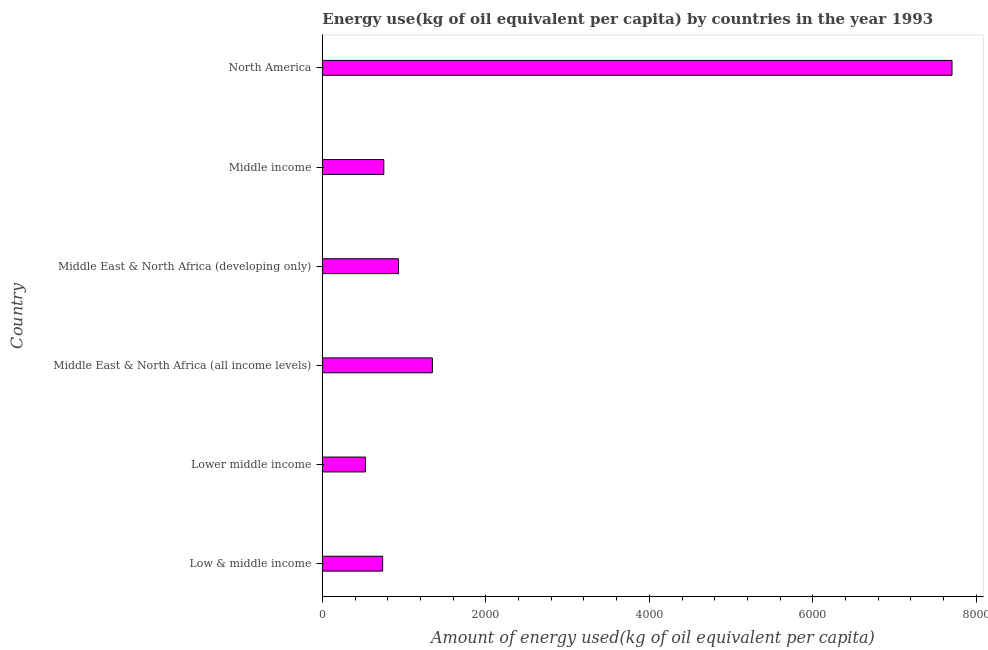Does the graph contain any zero values?
Provide a short and direct response. No. Does the graph contain grids?
Provide a succinct answer. No. What is the title of the graph?
Offer a terse response. Energy use(kg of oil equivalent per capita) by countries in the year 1993. What is the label or title of the X-axis?
Make the answer very short. Amount of energy used(kg of oil equivalent per capita). What is the amount of energy used in Lower middle income?
Keep it short and to the point. 527.1. Across all countries, what is the maximum amount of energy used?
Your answer should be compact. 7702.71. Across all countries, what is the minimum amount of energy used?
Provide a short and direct response. 527.1. In which country was the amount of energy used minimum?
Provide a succinct answer. Lower middle income. What is the sum of the amount of energy used?
Provide a short and direct response. 1.20e+04. What is the difference between the amount of energy used in Lower middle income and North America?
Your answer should be very brief. -7175.6. What is the average amount of energy used per country?
Offer a very short reply. 1999.72. What is the median amount of energy used?
Make the answer very short. 842.21. In how many countries, is the amount of energy used greater than 800 kg?
Your response must be concise. 3. What is the ratio of the amount of energy used in Middle East & North Africa (all income levels) to that in Middle income?
Offer a very short reply. 1.79. Is the difference between the amount of energy used in Middle East & North Africa (all income levels) and Middle income greater than the difference between any two countries?
Your answer should be very brief. No. What is the difference between the highest and the second highest amount of energy used?
Make the answer very short. 6356.54. Is the sum of the amount of energy used in Lower middle income and North America greater than the maximum amount of energy used across all countries?
Give a very brief answer. Yes. What is the difference between the highest and the lowest amount of energy used?
Keep it short and to the point. 7175.6. Are all the bars in the graph horizontal?
Ensure brevity in your answer.  Yes. What is the difference between two consecutive major ticks on the X-axis?
Ensure brevity in your answer.  2000. What is the Amount of energy used(kg of oil equivalent per capita) of Low & middle income?
Your answer should be very brief. 737.95. What is the Amount of energy used(kg of oil equivalent per capita) of Lower middle income?
Your response must be concise. 527.1. What is the Amount of energy used(kg of oil equivalent per capita) of Middle East & North Africa (all income levels)?
Your answer should be very brief. 1346.17. What is the Amount of energy used(kg of oil equivalent per capita) in Middle East & North Africa (developing only)?
Offer a terse response. 932.44. What is the Amount of energy used(kg of oil equivalent per capita) of Middle income?
Give a very brief answer. 751.97. What is the Amount of energy used(kg of oil equivalent per capita) of North America?
Your answer should be very brief. 7702.71. What is the difference between the Amount of energy used(kg of oil equivalent per capita) in Low & middle income and Lower middle income?
Provide a short and direct response. 210.84. What is the difference between the Amount of energy used(kg of oil equivalent per capita) in Low & middle income and Middle East & North Africa (all income levels)?
Ensure brevity in your answer.  -608.22. What is the difference between the Amount of energy used(kg of oil equivalent per capita) in Low & middle income and Middle East & North Africa (developing only)?
Make the answer very short. -194.49. What is the difference between the Amount of energy used(kg of oil equivalent per capita) in Low & middle income and Middle income?
Give a very brief answer. -14.02. What is the difference between the Amount of energy used(kg of oil equivalent per capita) in Low & middle income and North America?
Ensure brevity in your answer.  -6964.76. What is the difference between the Amount of energy used(kg of oil equivalent per capita) in Lower middle income and Middle East & North Africa (all income levels)?
Give a very brief answer. -819.07. What is the difference between the Amount of energy used(kg of oil equivalent per capita) in Lower middle income and Middle East & North Africa (developing only)?
Offer a very short reply. -405.34. What is the difference between the Amount of energy used(kg of oil equivalent per capita) in Lower middle income and Middle income?
Your response must be concise. -224.86. What is the difference between the Amount of energy used(kg of oil equivalent per capita) in Lower middle income and North America?
Give a very brief answer. -7175.6. What is the difference between the Amount of energy used(kg of oil equivalent per capita) in Middle East & North Africa (all income levels) and Middle East & North Africa (developing only)?
Ensure brevity in your answer.  413.73. What is the difference between the Amount of energy used(kg of oil equivalent per capita) in Middle East & North Africa (all income levels) and Middle income?
Your answer should be compact. 594.2. What is the difference between the Amount of energy used(kg of oil equivalent per capita) in Middle East & North Africa (all income levels) and North America?
Provide a succinct answer. -6356.54. What is the difference between the Amount of energy used(kg of oil equivalent per capita) in Middle East & North Africa (developing only) and Middle income?
Offer a terse response. 180.47. What is the difference between the Amount of energy used(kg of oil equivalent per capita) in Middle East & North Africa (developing only) and North America?
Provide a short and direct response. -6770.27. What is the difference between the Amount of energy used(kg of oil equivalent per capita) in Middle income and North America?
Keep it short and to the point. -6950.74. What is the ratio of the Amount of energy used(kg of oil equivalent per capita) in Low & middle income to that in Lower middle income?
Offer a very short reply. 1.4. What is the ratio of the Amount of energy used(kg of oil equivalent per capita) in Low & middle income to that in Middle East & North Africa (all income levels)?
Your answer should be very brief. 0.55. What is the ratio of the Amount of energy used(kg of oil equivalent per capita) in Low & middle income to that in Middle East & North Africa (developing only)?
Keep it short and to the point. 0.79. What is the ratio of the Amount of energy used(kg of oil equivalent per capita) in Low & middle income to that in North America?
Give a very brief answer. 0.1. What is the ratio of the Amount of energy used(kg of oil equivalent per capita) in Lower middle income to that in Middle East & North Africa (all income levels)?
Give a very brief answer. 0.39. What is the ratio of the Amount of energy used(kg of oil equivalent per capita) in Lower middle income to that in Middle East & North Africa (developing only)?
Provide a short and direct response. 0.56. What is the ratio of the Amount of energy used(kg of oil equivalent per capita) in Lower middle income to that in Middle income?
Ensure brevity in your answer.  0.7. What is the ratio of the Amount of energy used(kg of oil equivalent per capita) in Lower middle income to that in North America?
Your answer should be very brief. 0.07. What is the ratio of the Amount of energy used(kg of oil equivalent per capita) in Middle East & North Africa (all income levels) to that in Middle East & North Africa (developing only)?
Your answer should be very brief. 1.44. What is the ratio of the Amount of energy used(kg of oil equivalent per capita) in Middle East & North Africa (all income levels) to that in Middle income?
Your answer should be compact. 1.79. What is the ratio of the Amount of energy used(kg of oil equivalent per capita) in Middle East & North Africa (all income levels) to that in North America?
Provide a short and direct response. 0.17. What is the ratio of the Amount of energy used(kg of oil equivalent per capita) in Middle East & North Africa (developing only) to that in Middle income?
Give a very brief answer. 1.24. What is the ratio of the Amount of energy used(kg of oil equivalent per capita) in Middle East & North Africa (developing only) to that in North America?
Keep it short and to the point. 0.12. What is the ratio of the Amount of energy used(kg of oil equivalent per capita) in Middle income to that in North America?
Provide a succinct answer. 0.1. 